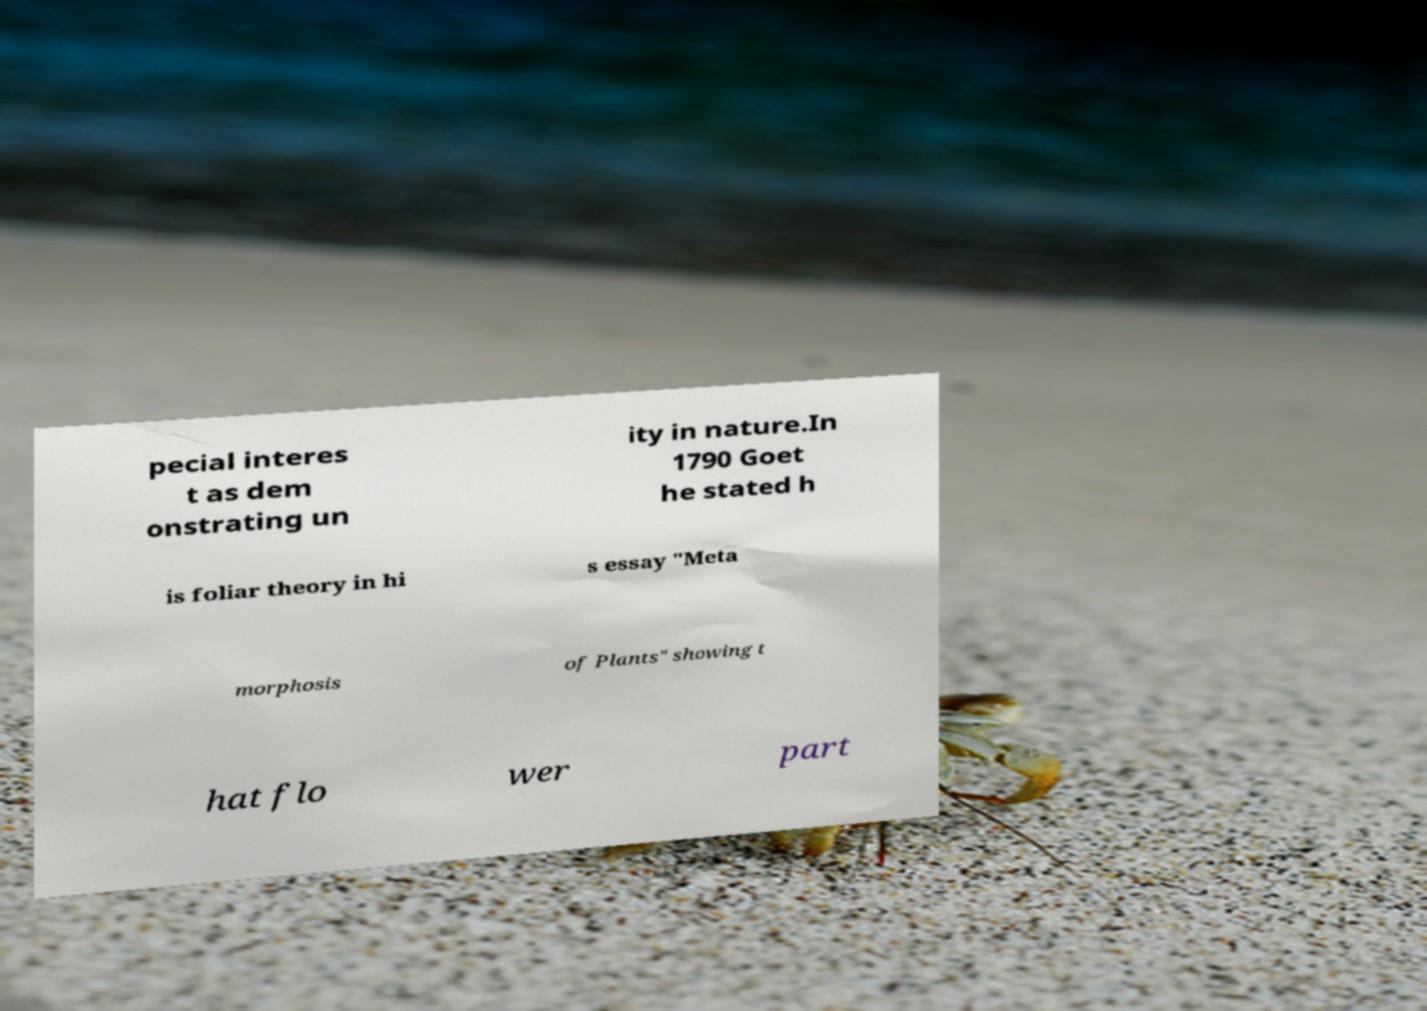Could you assist in decoding the text presented in this image and type it out clearly? pecial interes t as dem onstrating un ity in nature.In 1790 Goet he stated h is foliar theory in hi s essay "Meta morphosis of Plants" showing t hat flo wer part 